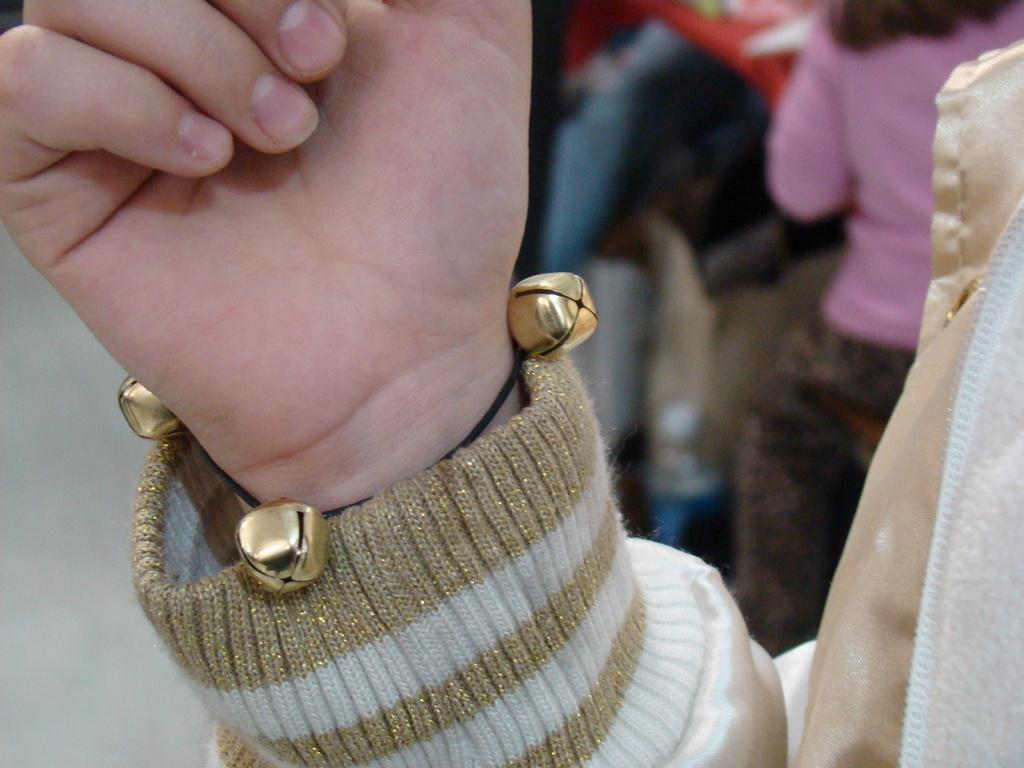What part of the body is visible in the image? There is a human hand in the image. What type of clothing is the person wearing? The person is wearing a sweater. What type of accessory is the person wearing? The person is wearing body jewelry. Can you describe the other person in the image? There is another person on the right side of the image. What type of nut is being cracked by the person in the image? There is no nut present in the image, and the person is not cracking a nut. 